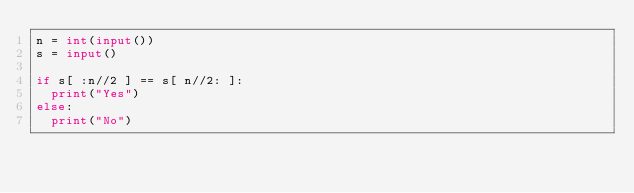<code> <loc_0><loc_0><loc_500><loc_500><_Python_>n = int(input())
s = input()

if s[ :n//2 ] == s[ n//2: ]:
  print("Yes")
else:
  print("No")</code> 